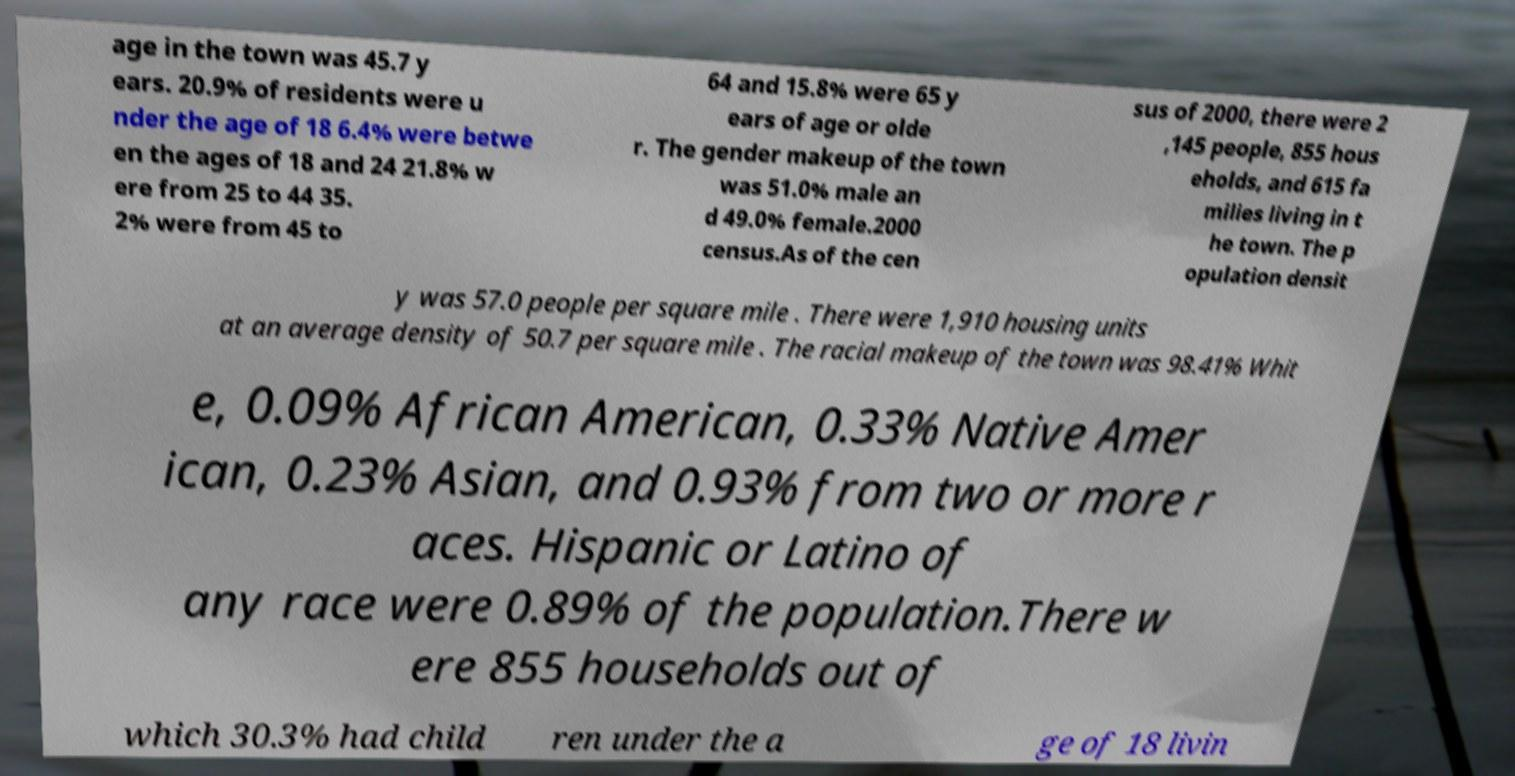For documentation purposes, I need the text within this image transcribed. Could you provide that? age in the town was 45.7 y ears. 20.9% of residents were u nder the age of 18 6.4% were betwe en the ages of 18 and 24 21.8% w ere from 25 to 44 35. 2% were from 45 to 64 and 15.8% were 65 y ears of age or olde r. The gender makeup of the town was 51.0% male an d 49.0% female.2000 census.As of the cen sus of 2000, there were 2 ,145 people, 855 hous eholds, and 615 fa milies living in t he town. The p opulation densit y was 57.0 people per square mile . There were 1,910 housing units at an average density of 50.7 per square mile . The racial makeup of the town was 98.41% Whit e, 0.09% African American, 0.33% Native Amer ican, 0.23% Asian, and 0.93% from two or more r aces. Hispanic or Latino of any race were 0.89% of the population.There w ere 855 households out of which 30.3% had child ren under the a ge of 18 livin 